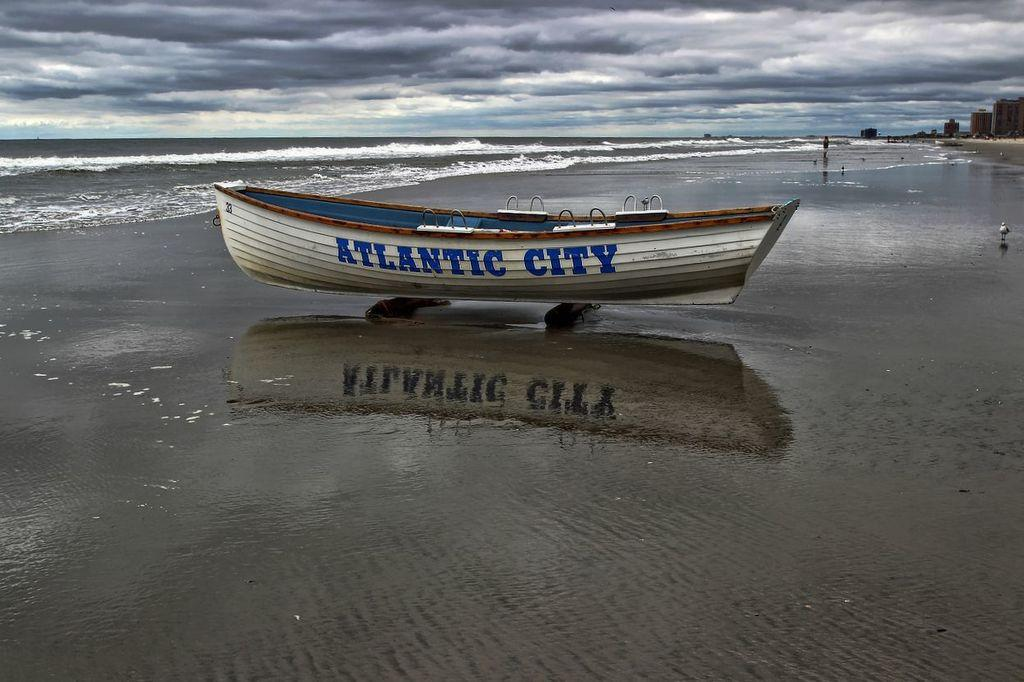What color is the boat in the image? The boat in the image is white. What can be seen on the boat? Something is written on the boat. What can be seen in the background of the image? There are birds, water, a cloudy sky, and buildings visible in the background. How does the ghost interact with the boat in the image? There is no ghost present in the image, so it cannot interact with the boat. 